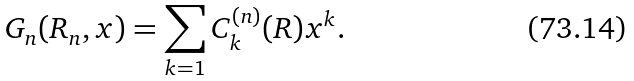<formula> <loc_0><loc_0><loc_500><loc_500>G _ { n } ( R _ { n } , x ) = \sum _ { k = 1 } C _ { k } ^ { ( n ) } ( R ) x ^ { k } .</formula> 